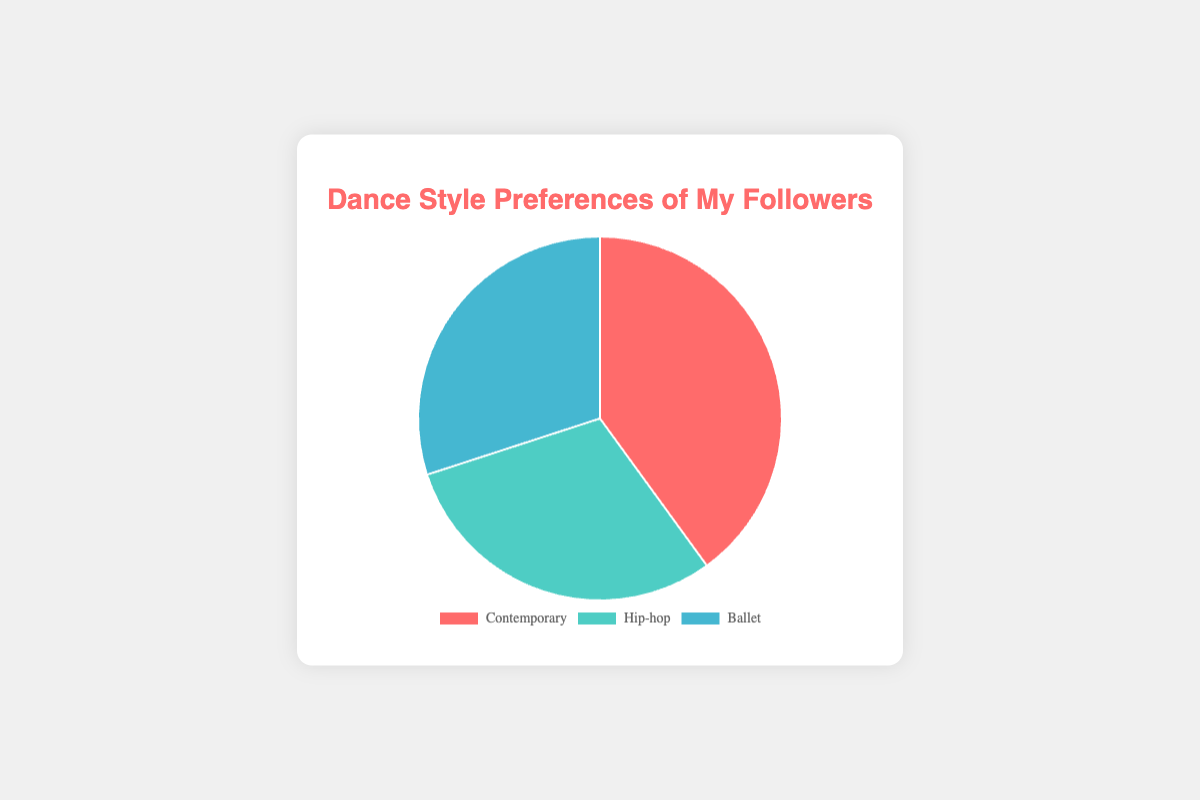How many of your followers prefer either Hip-hop or Ballet? Add the number of followers preferring Hip-hop (900) to those preferring Ballet (900): 900 + 900 = 1800
Answer: 1800 What percentage of your followers prefer dance styles other than Contemporary? Add the percentages of Hip-hop (30%) and Ballet (30%): 30 + 30 = 60%
Answer: 60% Which dance style is preferred by the highest number of your followers? From the data, Contemporary is preferred by 1200 followers, which is higher than Hip-hop (900) and Ballet (900)
Answer: Contemporary Between Hip-hop and Ballet, which dance style has more followers? Both Hip-hop and Ballet have the same number of followers, which is 900
Answer: They are equal How does the number of followers of Contemporary compare to the combined total of Hip-hop and Ballet? Compare Contemporary (1200) with the combined total of Hip-hop (900) and Ballet (900): 1200 vs 1800. 1200 is less than 1800
Answer: Less What color represents the Contemporary dance style in the pie chart? The background color used for Contemporary is red
Answer: Red If you add together the percentages of followers preferring Contemporary and Ballet, what is the result? Add the percentage for Contemporary (40%) and Ballet (30%): 40 + 30 = 70%
Answer: 70% What fraction of your followers prefer Hip-hop? The percentage is given as 30%. Thus, the fraction is 30/100 or simplified to 3/10
Answer: 3/10 Can you determine the median value of the number of followers for these dance styles? The number of followers are 1200 (Contemporary), 900 (Hip-hop), and 900 (Ballet). When ordered: 900, 900, 1200. The middle value is 900
Answer: 900 Which two dance styles have the same number of followers? Both Hip-hop and Ballet have 900 followers each
Answer: Hip-hop and Ballet 